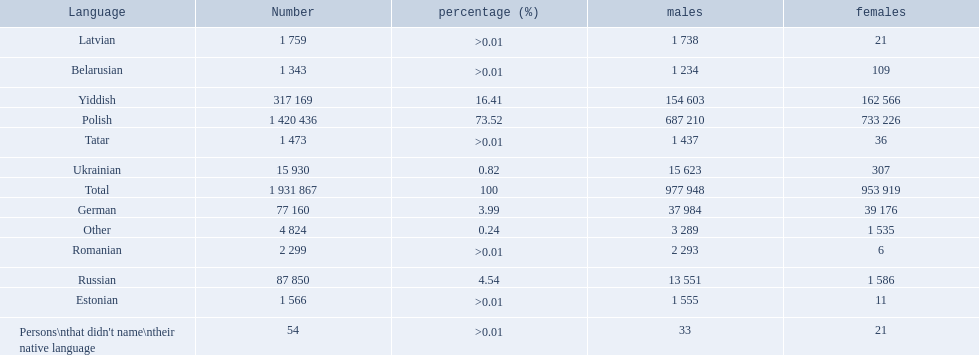How many languages are shown? Polish, Yiddish, Russian, German, Ukrainian, Romanian, Latvian, Estonian, Tatar, Belarusian, Other. What language is in third place? Russian. What language is the most spoken after that one? German. 